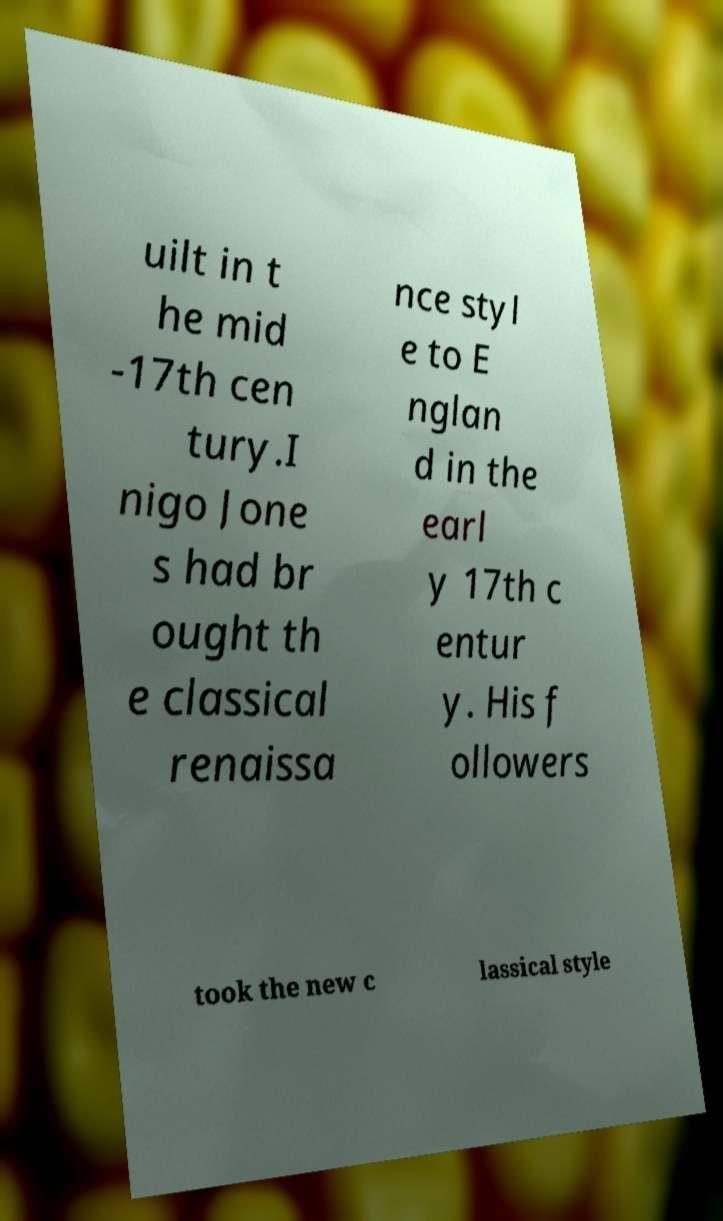Please read and relay the text visible in this image. What does it say? uilt in t he mid -17th cen tury.I nigo Jone s had br ought th e classical renaissa nce styl e to E nglan d in the earl y 17th c entur y. His f ollowers took the new c lassical style 